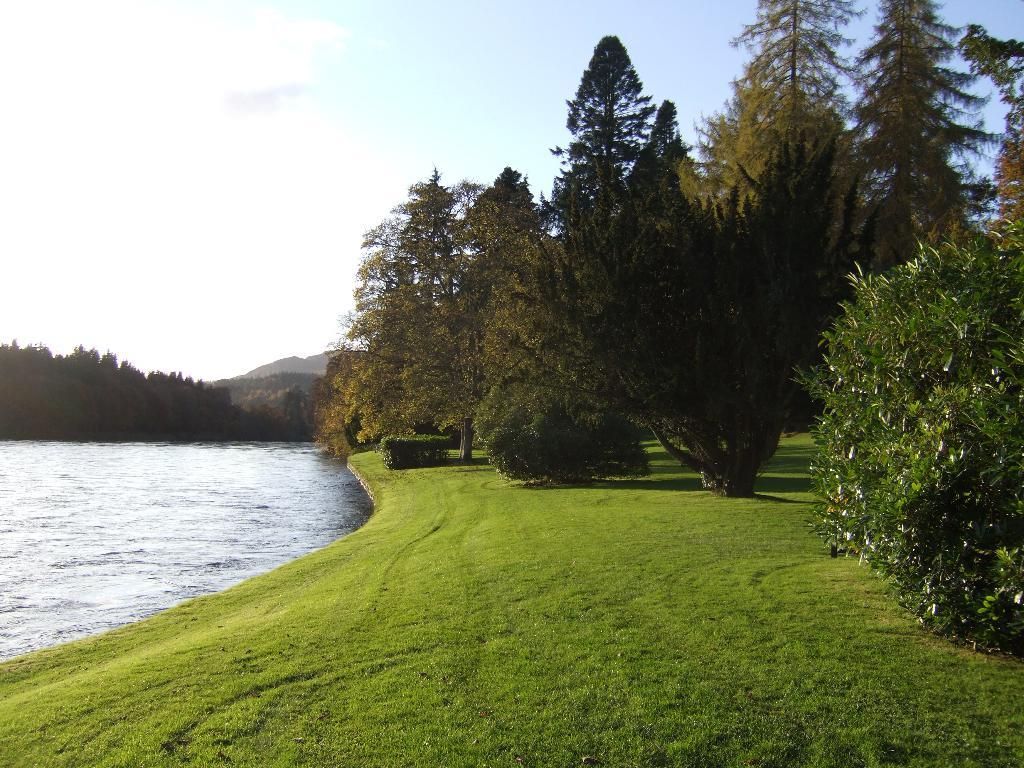What can be seen on the left side of the image? There is water on the left side of the image. What type of vegetation is present in the image? There are plants and trees in the image. What covers the ground in the image? There is grass on the ground in the image. What is visible in the background of the image? There are mountains and clouds in the blue sky in the background of the image. What type of drum can be seen in the image? There is no drum present in the image. Can you tell me how many cherries are on the trees in the image? There are no cherries mentioned in the image; it features include plants, trees, grass, mountains, and clouds. 